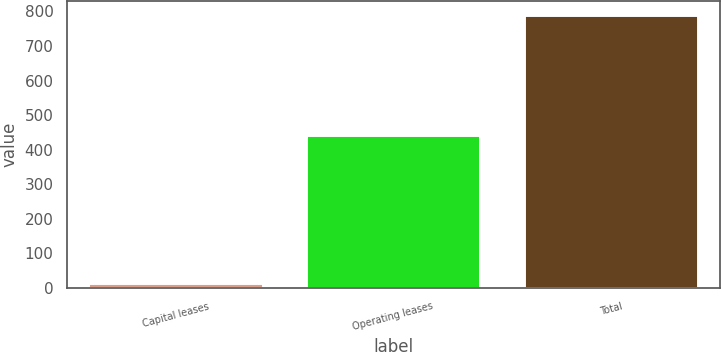Convert chart to OTSL. <chart><loc_0><loc_0><loc_500><loc_500><bar_chart><fcel>Capital leases<fcel>Operating leases<fcel>Total<nl><fcel>13.6<fcel>443.6<fcel>790.5<nl></chart> 